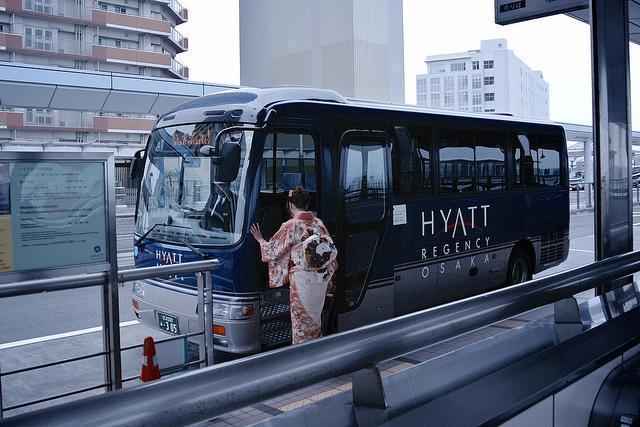In what city is this woman boarding the bus?
Indicate the correct response by choosing from the four available options to answer the question.
Options: Kyoto, osaka, kobe, tokyo. Osaka. 